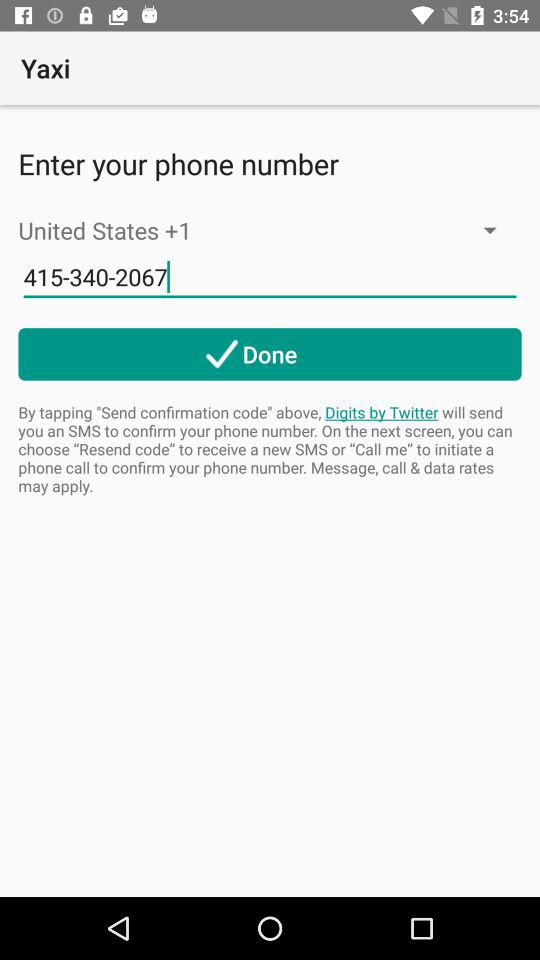How many digits are in the phone number?
Answer the question using a single word or phrase. 10 